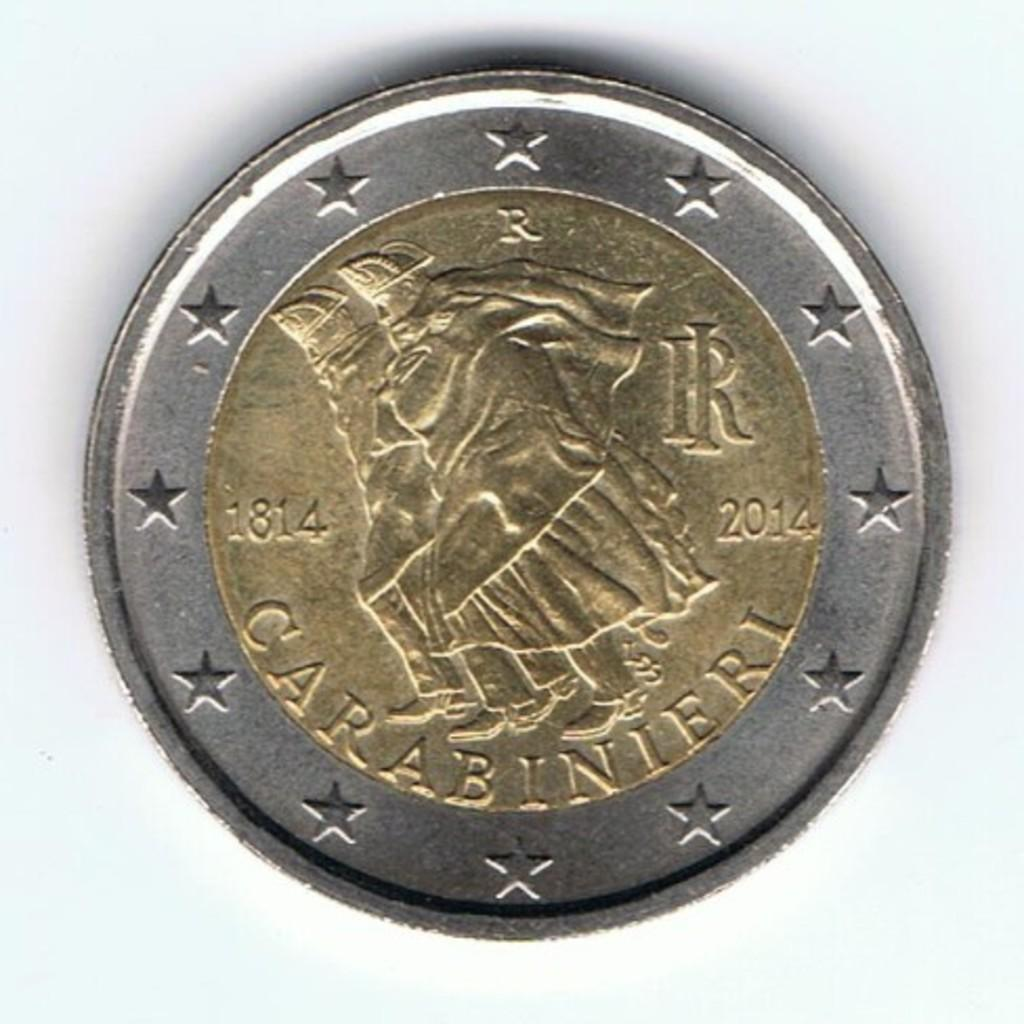Provide a one-sentence caption for the provided image. a coin dated 1814 and 2014 that says CARABINIERI on it. 